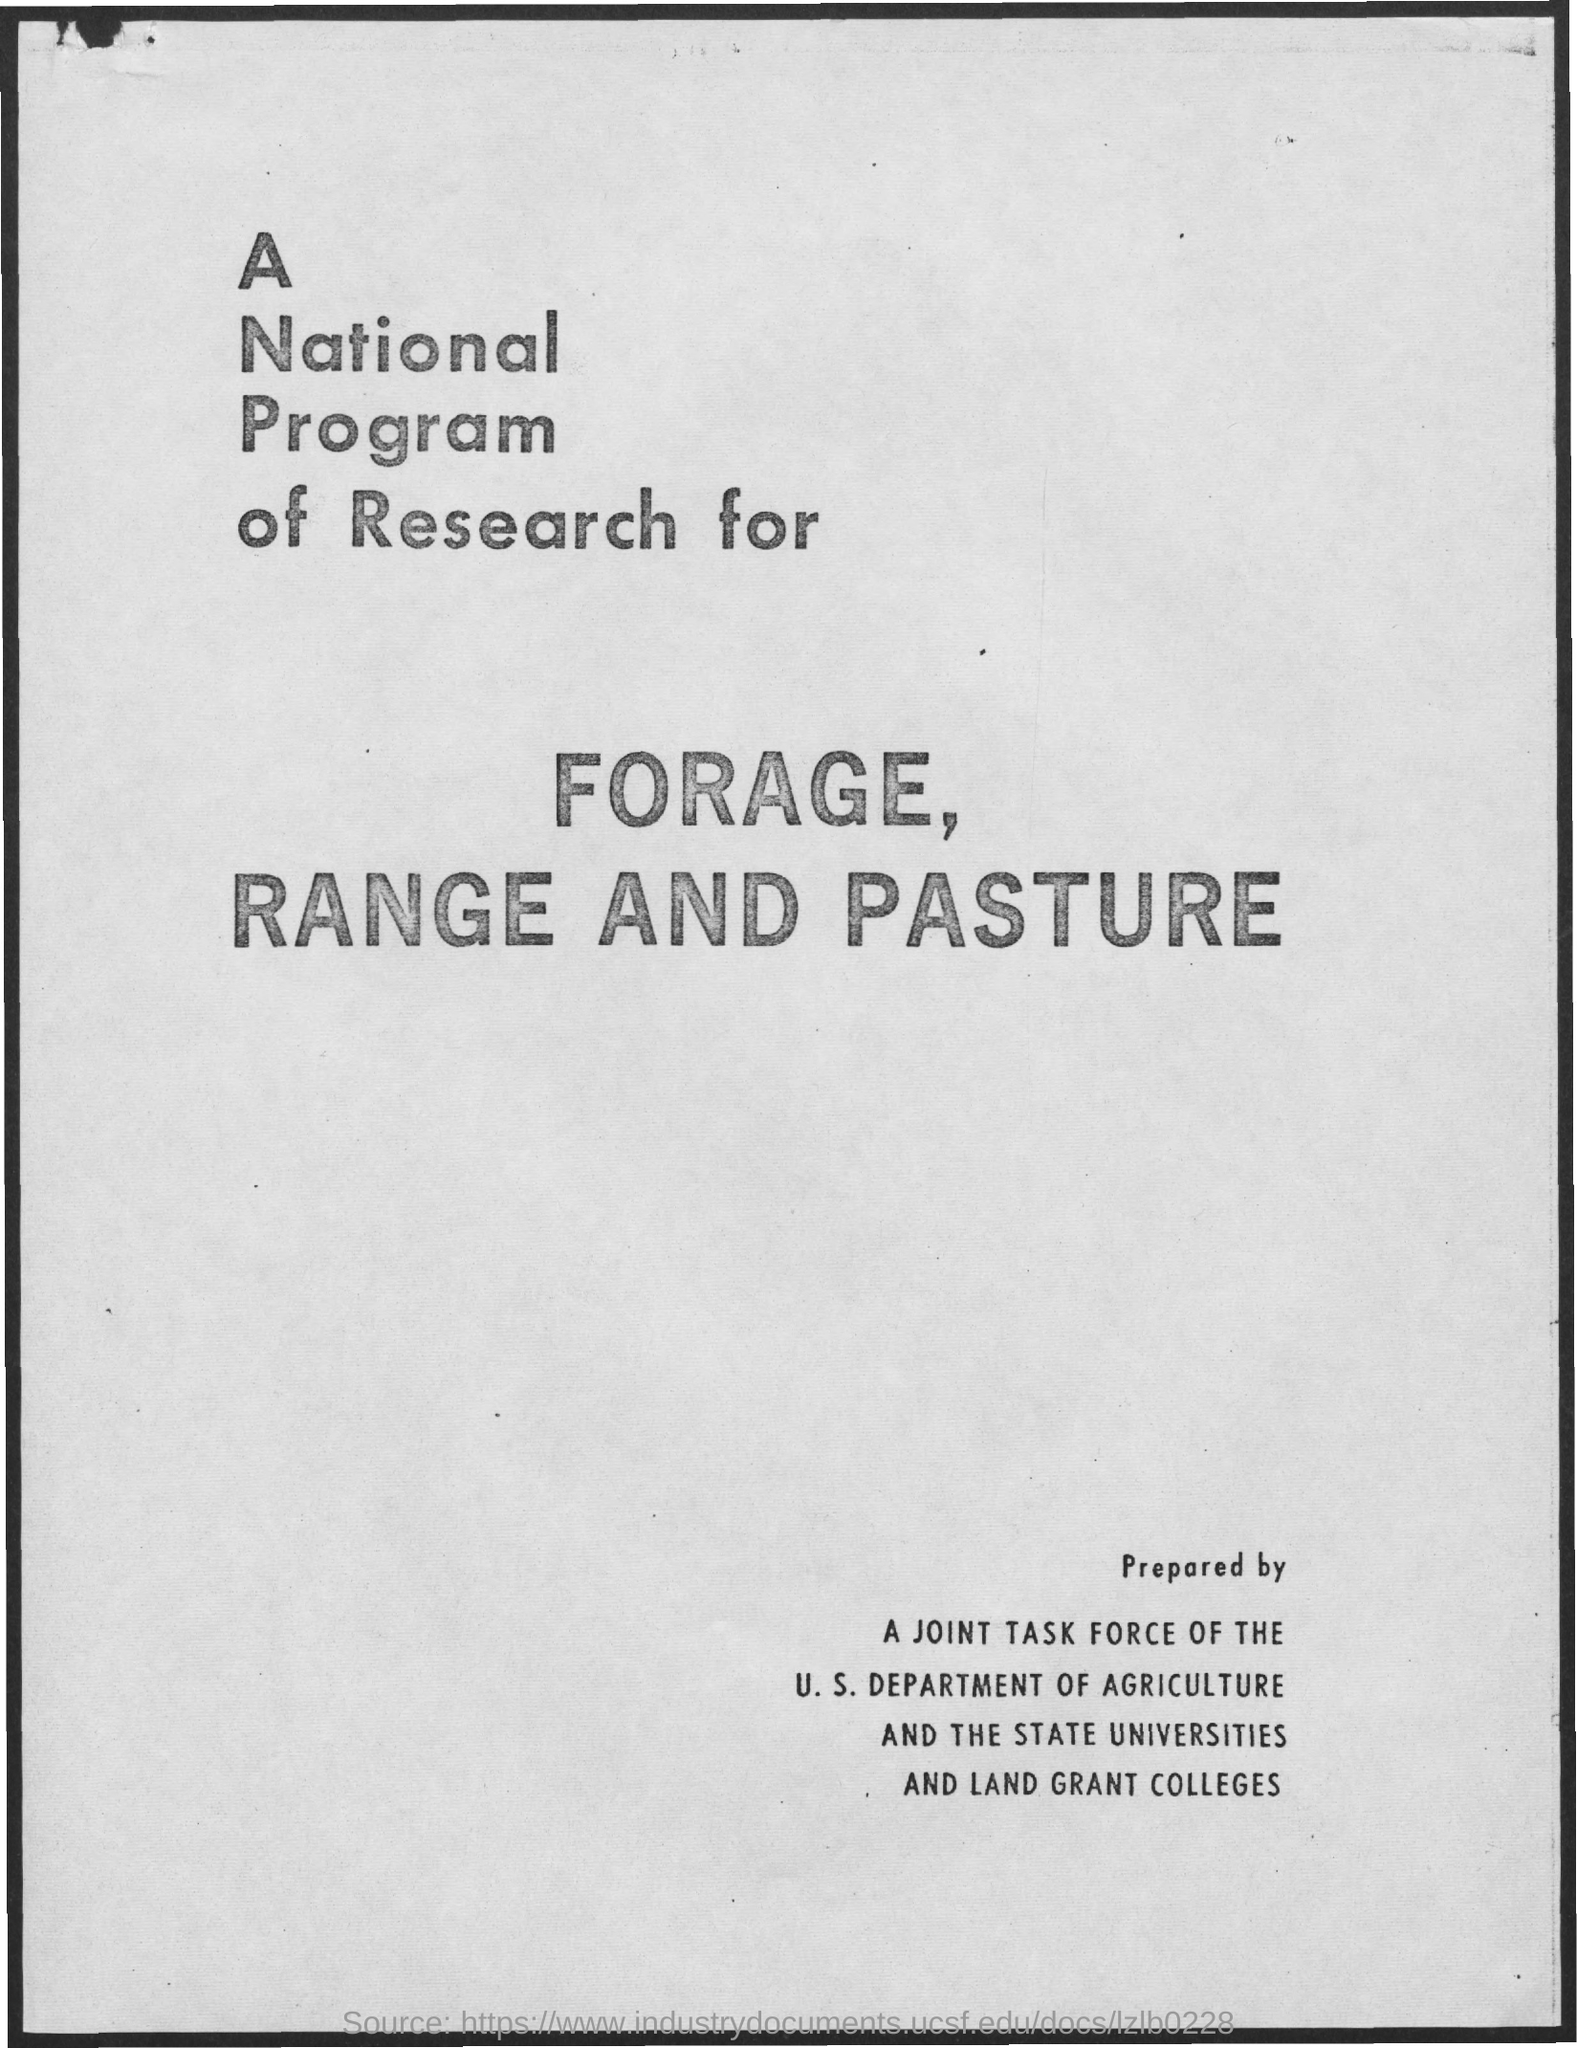Point out several critical features in this image. I hereby declare that the joint task force responsible for preparing this document is a collaboration between the U.S. Department of Agriculture and state universities and land grant colleges. The national program of research for forage, range, and pasture aims to advance knowledge and promote the sustainable management of these resources. 